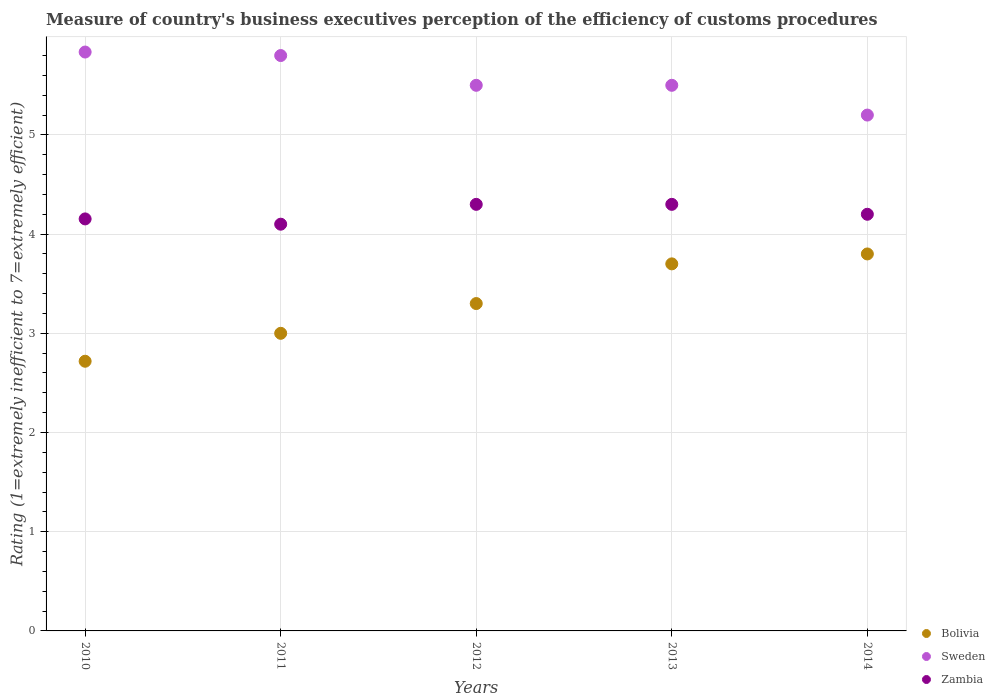Is the number of dotlines equal to the number of legend labels?
Your answer should be very brief. Yes. In which year was the rating of the efficiency of customs procedure in Bolivia maximum?
Provide a short and direct response. 2014. What is the total rating of the efficiency of customs procedure in Sweden in the graph?
Your answer should be compact. 27.84. What is the difference between the rating of the efficiency of customs procedure in Sweden in 2010 and that in 2014?
Make the answer very short. 0.64. What is the difference between the rating of the efficiency of customs procedure in Sweden in 2013 and the rating of the efficiency of customs procedure in Bolivia in 2014?
Keep it short and to the point. 1.7. What is the average rating of the efficiency of customs procedure in Sweden per year?
Provide a short and direct response. 5.57. In how many years, is the rating of the efficiency of customs procedure in Sweden greater than 0.8?
Give a very brief answer. 5. What is the ratio of the rating of the efficiency of customs procedure in Bolivia in 2012 to that in 2014?
Offer a terse response. 0.87. Is the rating of the efficiency of customs procedure in Sweden in 2010 less than that in 2012?
Give a very brief answer. No. Is the difference between the rating of the efficiency of customs procedure in Bolivia in 2010 and 2014 greater than the difference between the rating of the efficiency of customs procedure in Sweden in 2010 and 2014?
Your answer should be very brief. No. What is the difference between the highest and the second highest rating of the efficiency of customs procedure in Sweden?
Ensure brevity in your answer.  0.04. What is the difference between the highest and the lowest rating of the efficiency of customs procedure in Sweden?
Offer a very short reply. 0.64. Is it the case that in every year, the sum of the rating of the efficiency of customs procedure in Sweden and rating of the efficiency of customs procedure in Bolivia  is greater than the rating of the efficiency of customs procedure in Zambia?
Your answer should be compact. Yes. Is the rating of the efficiency of customs procedure in Sweden strictly less than the rating of the efficiency of customs procedure in Zambia over the years?
Keep it short and to the point. No. How many dotlines are there?
Ensure brevity in your answer.  3. What is the difference between two consecutive major ticks on the Y-axis?
Ensure brevity in your answer.  1. Are the values on the major ticks of Y-axis written in scientific E-notation?
Offer a terse response. No. Does the graph contain any zero values?
Give a very brief answer. No. How are the legend labels stacked?
Provide a succinct answer. Vertical. What is the title of the graph?
Make the answer very short. Measure of country's business executives perception of the efficiency of customs procedures. What is the label or title of the Y-axis?
Make the answer very short. Rating (1=extremely inefficient to 7=extremely efficient). What is the Rating (1=extremely inefficient to 7=extremely efficient) in Bolivia in 2010?
Ensure brevity in your answer.  2.72. What is the Rating (1=extremely inefficient to 7=extremely efficient) in Sweden in 2010?
Offer a very short reply. 5.84. What is the Rating (1=extremely inefficient to 7=extremely efficient) in Zambia in 2010?
Your response must be concise. 4.15. What is the Rating (1=extremely inefficient to 7=extremely efficient) of Zambia in 2011?
Offer a terse response. 4.1. What is the Rating (1=extremely inefficient to 7=extremely efficient) of Bolivia in 2012?
Provide a short and direct response. 3.3. What is the Rating (1=extremely inefficient to 7=extremely efficient) of Bolivia in 2013?
Ensure brevity in your answer.  3.7. What is the Rating (1=extremely inefficient to 7=extremely efficient) of Sweden in 2013?
Keep it short and to the point. 5.5. Across all years, what is the maximum Rating (1=extremely inefficient to 7=extremely efficient) in Bolivia?
Your response must be concise. 3.8. Across all years, what is the maximum Rating (1=extremely inefficient to 7=extremely efficient) of Sweden?
Offer a very short reply. 5.84. Across all years, what is the minimum Rating (1=extremely inefficient to 7=extremely efficient) of Bolivia?
Offer a very short reply. 2.72. Across all years, what is the minimum Rating (1=extremely inefficient to 7=extremely efficient) in Zambia?
Your answer should be very brief. 4.1. What is the total Rating (1=extremely inefficient to 7=extremely efficient) of Bolivia in the graph?
Give a very brief answer. 16.52. What is the total Rating (1=extremely inefficient to 7=extremely efficient) in Sweden in the graph?
Provide a short and direct response. 27.84. What is the total Rating (1=extremely inefficient to 7=extremely efficient) in Zambia in the graph?
Your response must be concise. 21.05. What is the difference between the Rating (1=extremely inefficient to 7=extremely efficient) of Bolivia in 2010 and that in 2011?
Keep it short and to the point. -0.28. What is the difference between the Rating (1=extremely inefficient to 7=extremely efficient) in Sweden in 2010 and that in 2011?
Your response must be concise. 0.04. What is the difference between the Rating (1=extremely inefficient to 7=extremely efficient) in Zambia in 2010 and that in 2011?
Your answer should be compact. 0.05. What is the difference between the Rating (1=extremely inefficient to 7=extremely efficient) in Bolivia in 2010 and that in 2012?
Keep it short and to the point. -0.58. What is the difference between the Rating (1=extremely inefficient to 7=extremely efficient) in Sweden in 2010 and that in 2012?
Keep it short and to the point. 0.34. What is the difference between the Rating (1=extremely inefficient to 7=extremely efficient) of Zambia in 2010 and that in 2012?
Offer a very short reply. -0.15. What is the difference between the Rating (1=extremely inefficient to 7=extremely efficient) of Bolivia in 2010 and that in 2013?
Offer a very short reply. -0.98. What is the difference between the Rating (1=extremely inefficient to 7=extremely efficient) of Sweden in 2010 and that in 2013?
Your answer should be compact. 0.34. What is the difference between the Rating (1=extremely inefficient to 7=extremely efficient) of Zambia in 2010 and that in 2013?
Make the answer very short. -0.15. What is the difference between the Rating (1=extremely inefficient to 7=extremely efficient) of Bolivia in 2010 and that in 2014?
Provide a succinct answer. -1.08. What is the difference between the Rating (1=extremely inefficient to 7=extremely efficient) in Sweden in 2010 and that in 2014?
Your response must be concise. 0.64. What is the difference between the Rating (1=extremely inefficient to 7=extremely efficient) in Zambia in 2010 and that in 2014?
Give a very brief answer. -0.05. What is the difference between the Rating (1=extremely inefficient to 7=extremely efficient) of Bolivia in 2011 and that in 2012?
Your answer should be compact. -0.3. What is the difference between the Rating (1=extremely inefficient to 7=extremely efficient) in Sweden in 2011 and that in 2012?
Your response must be concise. 0.3. What is the difference between the Rating (1=extremely inefficient to 7=extremely efficient) of Bolivia in 2011 and that in 2013?
Your answer should be very brief. -0.7. What is the difference between the Rating (1=extremely inefficient to 7=extremely efficient) in Zambia in 2011 and that in 2013?
Keep it short and to the point. -0.2. What is the difference between the Rating (1=extremely inefficient to 7=extremely efficient) in Bolivia in 2011 and that in 2014?
Give a very brief answer. -0.8. What is the difference between the Rating (1=extremely inefficient to 7=extremely efficient) of Bolivia in 2012 and that in 2013?
Offer a very short reply. -0.4. What is the difference between the Rating (1=extremely inefficient to 7=extremely efficient) of Zambia in 2012 and that in 2013?
Ensure brevity in your answer.  0. What is the difference between the Rating (1=extremely inefficient to 7=extremely efficient) of Bolivia in 2012 and that in 2014?
Keep it short and to the point. -0.5. What is the difference between the Rating (1=extremely inefficient to 7=extremely efficient) of Zambia in 2012 and that in 2014?
Offer a very short reply. 0.1. What is the difference between the Rating (1=extremely inefficient to 7=extremely efficient) in Bolivia in 2013 and that in 2014?
Your response must be concise. -0.1. What is the difference between the Rating (1=extremely inefficient to 7=extremely efficient) of Zambia in 2013 and that in 2014?
Provide a succinct answer. 0.1. What is the difference between the Rating (1=extremely inefficient to 7=extremely efficient) of Bolivia in 2010 and the Rating (1=extremely inefficient to 7=extremely efficient) of Sweden in 2011?
Your answer should be compact. -3.08. What is the difference between the Rating (1=extremely inefficient to 7=extremely efficient) of Bolivia in 2010 and the Rating (1=extremely inefficient to 7=extremely efficient) of Zambia in 2011?
Provide a short and direct response. -1.38. What is the difference between the Rating (1=extremely inefficient to 7=extremely efficient) of Sweden in 2010 and the Rating (1=extremely inefficient to 7=extremely efficient) of Zambia in 2011?
Keep it short and to the point. 1.74. What is the difference between the Rating (1=extremely inefficient to 7=extremely efficient) of Bolivia in 2010 and the Rating (1=extremely inefficient to 7=extremely efficient) of Sweden in 2012?
Ensure brevity in your answer.  -2.78. What is the difference between the Rating (1=extremely inefficient to 7=extremely efficient) in Bolivia in 2010 and the Rating (1=extremely inefficient to 7=extremely efficient) in Zambia in 2012?
Ensure brevity in your answer.  -1.58. What is the difference between the Rating (1=extremely inefficient to 7=extremely efficient) of Sweden in 2010 and the Rating (1=extremely inefficient to 7=extremely efficient) of Zambia in 2012?
Your answer should be compact. 1.54. What is the difference between the Rating (1=extremely inefficient to 7=extremely efficient) in Bolivia in 2010 and the Rating (1=extremely inefficient to 7=extremely efficient) in Sweden in 2013?
Your answer should be compact. -2.78. What is the difference between the Rating (1=extremely inefficient to 7=extremely efficient) in Bolivia in 2010 and the Rating (1=extremely inefficient to 7=extremely efficient) in Zambia in 2013?
Keep it short and to the point. -1.58. What is the difference between the Rating (1=extremely inefficient to 7=extremely efficient) of Sweden in 2010 and the Rating (1=extremely inefficient to 7=extremely efficient) of Zambia in 2013?
Offer a terse response. 1.54. What is the difference between the Rating (1=extremely inefficient to 7=extremely efficient) of Bolivia in 2010 and the Rating (1=extremely inefficient to 7=extremely efficient) of Sweden in 2014?
Keep it short and to the point. -2.48. What is the difference between the Rating (1=extremely inefficient to 7=extremely efficient) of Bolivia in 2010 and the Rating (1=extremely inefficient to 7=extremely efficient) of Zambia in 2014?
Offer a terse response. -1.48. What is the difference between the Rating (1=extremely inefficient to 7=extremely efficient) in Sweden in 2010 and the Rating (1=extremely inefficient to 7=extremely efficient) in Zambia in 2014?
Make the answer very short. 1.64. What is the difference between the Rating (1=extremely inefficient to 7=extremely efficient) of Bolivia in 2011 and the Rating (1=extremely inefficient to 7=extremely efficient) of Zambia in 2012?
Give a very brief answer. -1.3. What is the difference between the Rating (1=extremely inefficient to 7=extremely efficient) of Bolivia in 2011 and the Rating (1=extremely inefficient to 7=extremely efficient) of Zambia in 2013?
Keep it short and to the point. -1.3. What is the difference between the Rating (1=extremely inefficient to 7=extremely efficient) of Bolivia in 2011 and the Rating (1=extremely inefficient to 7=extremely efficient) of Sweden in 2014?
Your response must be concise. -2.2. What is the difference between the Rating (1=extremely inefficient to 7=extremely efficient) of Bolivia in 2011 and the Rating (1=extremely inefficient to 7=extremely efficient) of Zambia in 2014?
Your answer should be compact. -1.2. What is the difference between the Rating (1=extremely inefficient to 7=extremely efficient) in Bolivia in 2012 and the Rating (1=extremely inefficient to 7=extremely efficient) in Zambia in 2013?
Provide a succinct answer. -1. What is the difference between the Rating (1=extremely inefficient to 7=extremely efficient) of Sweden in 2012 and the Rating (1=extremely inefficient to 7=extremely efficient) of Zambia in 2013?
Offer a very short reply. 1.2. What is the difference between the Rating (1=extremely inefficient to 7=extremely efficient) of Sweden in 2012 and the Rating (1=extremely inefficient to 7=extremely efficient) of Zambia in 2014?
Your answer should be very brief. 1.3. What is the difference between the Rating (1=extremely inefficient to 7=extremely efficient) of Bolivia in 2013 and the Rating (1=extremely inefficient to 7=extremely efficient) of Zambia in 2014?
Your response must be concise. -0.5. What is the average Rating (1=extremely inefficient to 7=extremely efficient) of Bolivia per year?
Offer a very short reply. 3.3. What is the average Rating (1=extremely inefficient to 7=extremely efficient) of Sweden per year?
Give a very brief answer. 5.57. What is the average Rating (1=extremely inefficient to 7=extremely efficient) of Zambia per year?
Offer a terse response. 4.21. In the year 2010, what is the difference between the Rating (1=extremely inefficient to 7=extremely efficient) of Bolivia and Rating (1=extremely inefficient to 7=extremely efficient) of Sweden?
Offer a terse response. -3.12. In the year 2010, what is the difference between the Rating (1=extremely inefficient to 7=extremely efficient) in Bolivia and Rating (1=extremely inefficient to 7=extremely efficient) in Zambia?
Give a very brief answer. -1.43. In the year 2010, what is the difference between the Rating (1=extremely inefficient to 7=extremely efficient) of Sweden and Rating (1=extremely inefficient to 7=extremely efficient) of Zambia?
Provide a succinct answer. 1.68. In the year 2011, what is the difference between the Rating (1=extremely inefficient to 7=extremely efficient) in Bolivia and Rating (1=extremely inefficient to 7=extremely efficient) in Sweden?
Provide a short and direct response. -2.8. In the year 2012, what is the difference between the Rating (1=extremely inefficient to 7=extremely efficient) in Bolivia and Rating (1=extremely inefficient to 7=extremely efficient) in Sweden?
Your answer should be compact. -2.2. In the year 2012, what is the difference between the Rating (1=extremely inefficient to 7=extremely efficient) of Bolivia and Rating (1=extremely inefficient to 7=extremely efficient) of Zambia?
Offer a very short reply. -1. In the year 2012, what is the difference between the Rating (1=extremely inefficient to 7=extremely efficient) in Sweden and Rating (1=extremely inefficient to 7=extremely efficient) in Zambia?
Make the answer very short. 1.2. In the year 2013, what is the difference between the Rating (1=extremely inefficient to 7=extremely efficient) in Bolivia and Rating (1=extremely inefficient to 7=extremely efficient) in Sweden?
Your answer should be very brief. -1.8. In the year 2013, what is the difference between the Rating (1=extremely inefficient to 7=extremely efficient) of Sweden and Rating (1=extremely inefficient to 7=extremely efficient) of Zambia?
Your response must be concise. 1.2. In the year 2014, what is the difference between the Rating (1=extremely inefficient to 7=extremely efficient) of Sweden and Rating (1=extremely inefficient to 7=extremely efficient) of Zambia?
Your response must be concise. 1. What is the ratio of the Rating (1=extremely inefficient to 7=extremely efficient) in Bolivia in 2010 to that in 2011?
Your response must be concise. 0.91. What is the ratio of the Rating (1=extremely inefficient to 7=extremely efficient) in Bolivia in 2010 to that in 2012?
Keep it short and to the point. 0.82. What is the ratio of the Rating (1=extremely inefficient to 7=extremely efficient) of Sweden in 2010 to that in 2012?
Offer a very short reply. 1.06. What is the ratio of the Rating (1=extremely inefficient to 7=extremely efficient) in Zambia in 2010 to that in 2012?
Offer a very short reply. 0.97. What is the ratio of the Rating (1=extremely inefficient to 7=extremely efficient) of Bolivia in 2010 to that in 2013?
Offer a very short reply. 0.73. What is the ratio of the Rating (1=extremely inefficient to 7=extremely efficient) in Sweden in 2010 to that in 2013?
Offer a very short reply. 1.06. What is the ratio of the Rating (1=extremely inefficient to 7=extremely efficient) in Zambia in 2010 to that in 2013?
Ensure brevity in your answer.  0.97. What is the ratio of the Rating (1=extremely inefficient to 7=extremely efficient) in Bolivia in 2010 to that in 2014?
Your response must be concise. 0.72. What is the ratio of the Rating (1=extremely inefficient to 7=extremely efficient) in Sweden in 2010 to that in 2014?
Your answer should be compact. 1.12. What is the ratio of the Rating (1=extremely inefficient to 7=extremely efficient) in Zambia in 2010 to that in 2014?
Offer a very short reply. 0.99. What is the ratio of the Rating (1=extremely inefficient to 7=extremely efficient) of Bolivia in 2011 to that in 2012?
Your answer should be very brief. 0.91. What is the ratio of the Rating (1=extremely inefficient to 7=extremely efficient) of Sweden in 2011 to that in 2012?
Make the answer very short. 1.05. What is the ratio of the Rating (1=extremely inefficient to 7=extremely efficient) of Zambia in 2011 to that in 2012?
Provide a succinct answer. 0.95. What is the ratio of the Rating (1=extremely inefficient to 7=extremely efficient) of Bolivia in 2011 to that in 2013?
Your answer should be compact. 0.81. What is the ratio of the Rating (1=extremely inefficient to 7=extremely efficient) in Sweden in 2011 to that in 2013?
Keep it short and to the point. 1.05. What is the ratio of the Rating (1=extremely inefficient to 7=extremely efficient) in Zambia in 2011 to that in 2013?
Your answer should be compact. 0.95. What is the ratio of the Rating (1=extremely inefficient to 7=extremely efficient) in Bolivia in 2011 to that in 2014?
Offer a very short reply. 0.79. What is the ratio of the Rating (1=extremely inefficient to 7=extremely efficient) in Sweden in 2011 to that in 2014?
Offer a very short reply. 1.12. What is the ratio of the Rating (1=extremely inefficient to 7=extremely efficient) of Zambia in 2011 to that in 2014?
Your answer should be very brief. 0.98. What is the ratio of the Rating (1=extremely inefficient to 7=extremely efficient) of Bolivia in 2012 to that in 2013?
Offer a terse response. 0.89. What is the ratio of the Rating (1=extremely inefficient to 7=extremely efficient) in Sweden in 2012 to that in 2013?
Your answer should be compact. 1. What is the ratio of the Rating (1=extremely inefficient to 7=extremely efficient) of Bolivia in 2012 to that in 2014?
Your answer should be compact. 0.87. What is the ratio of the Rating (1=extremely inefficient to 7=extremely efficient) of Sweden in 2012 to that in 2014?
Provide a short and direct response. 1.06. What is the ratio of the Rating (1=extremely inefficient to 7=extremely efficient) of Zambia in 2012 to that in 2014?
Provide a succinct answer. 1.02. What is the ratio of the Rating (1=extremely inefficient to 7=extremely efficient) in Bolivia in 2013 to that in 2014?
Give a very brief answer. 0.97. What is the ratio of the Rating (1=extremely inefficient to 7=extremely efficient) in Sweden in 2013 to that in 2014?
Your answer should be very brief. 1.06. What is the ratio of the Rating (1=extremely inefficient to 7=extremely efficient) in Zambia in 2013 to that in 2014?
Offer a terse response. 1.02. What is the difference between the highest and the second highest Rating (1=extremely inefficient to 7=extremely efficient) in Bolivia?
Offer a very short reply. 0.1. What is the difference between the highest and the second highest Rating (1=extremely inefficient to 7=extremely efficient) of Sweden?
Your response must be concise. 0.04. What is the difference between the highest and the lowest Rating (1=extremely inefficient to 7=extremely efficient) in Bolivia?
Provide a short and direct response. 1.08. What is the difference between the highest and the lowest Rating (1=extremely inefficient to 7=extremely efficient) of Sweden?
Provide a succinct answer. 0.64. What is the difference between the highest and the lowest Rating (1=extremely inefficient to 7=extremely efficient) in Zambia?
Provide a short and direct response. 0.2. 